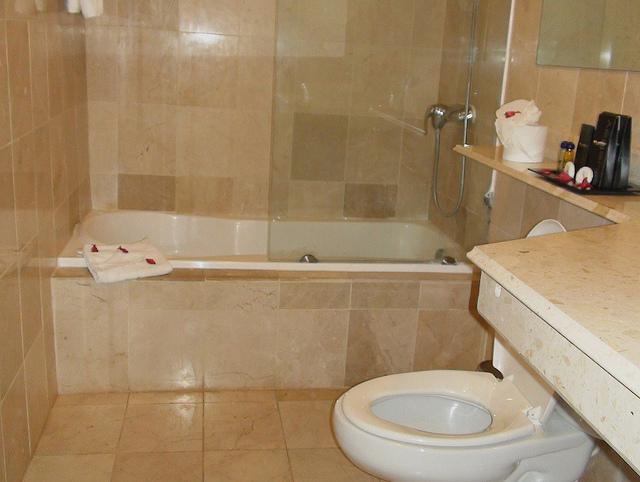Is the toilet beside the sink?
Give a very brief answer. Yes. Is the toilet lid down?
Answer briefly. No. Has this room been cleaned?
Answer briefly. Yes. Has this room recently been cleaned?
Short answer required. Yes. What are the reddish things on the towel?
Keep it brief. Rose petals. 